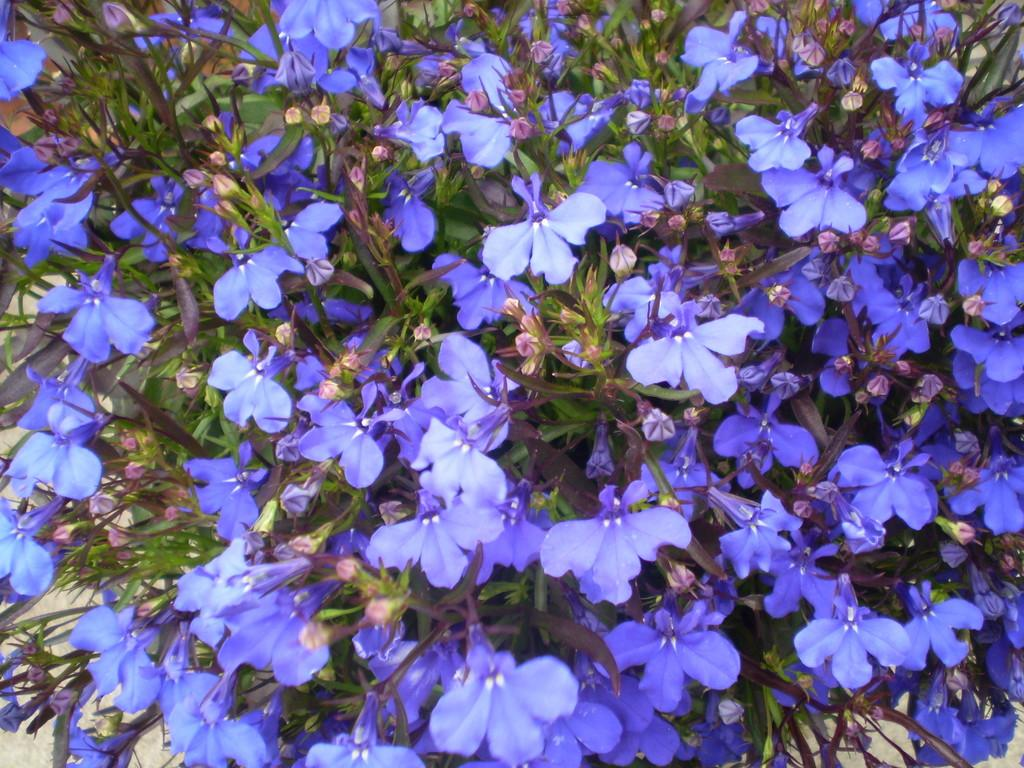What type of living organisms can be seen in the image? Plants can be seen in the image. What specific features can be observed on the plants? The plants have flowers and buds. What type of credit can be seen on the plants in the image? There is no credit visible on the plants in the image. What type of cabbage is growing among the plants in the image? There is no cabbage present in the image; it only features plants with flowers and buds. 